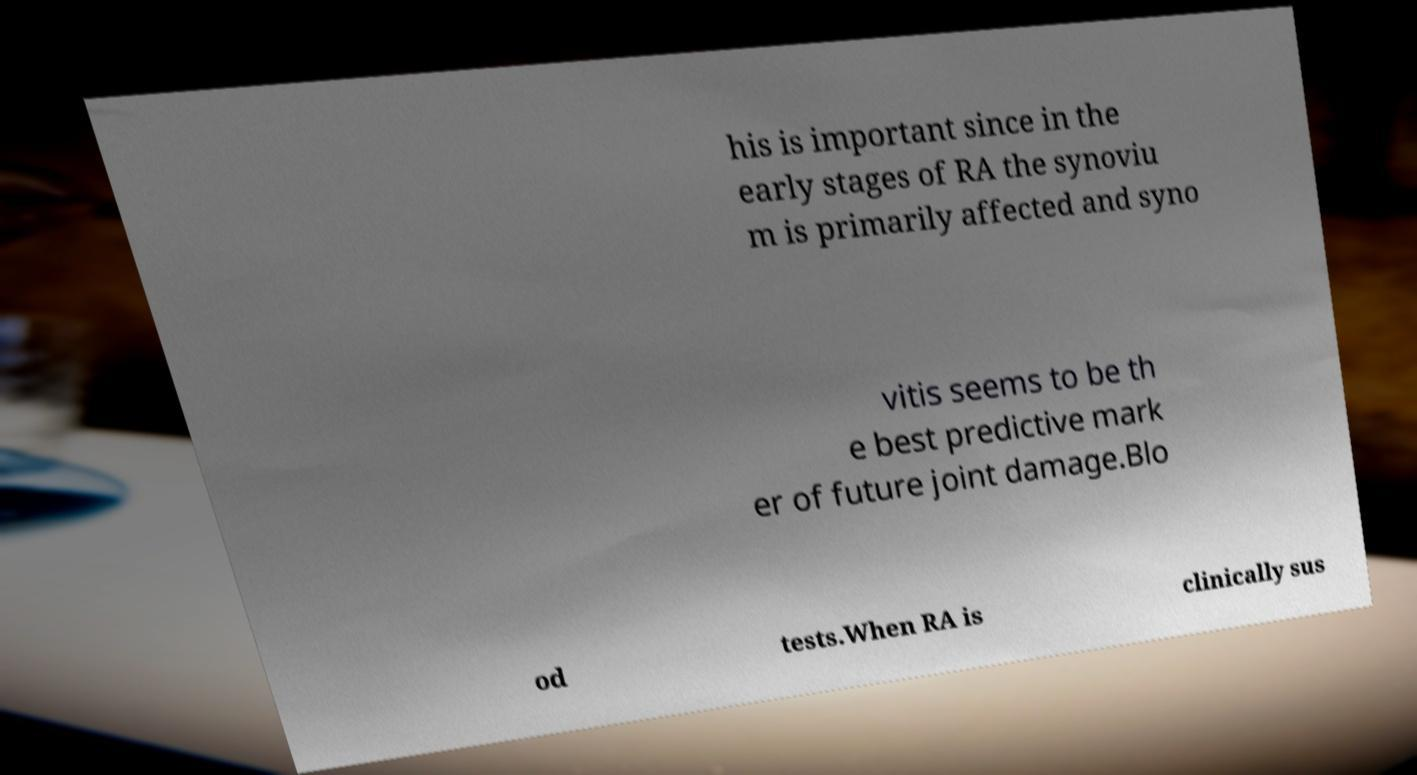Please read and relay the text visible in this image. What does it say? his is important since in the early stages of RA the synoviu m is primarily affected and syno vitis seems to be th e best predictive mark er of future joint damage.Blo od tests.When RA is clinically sus 